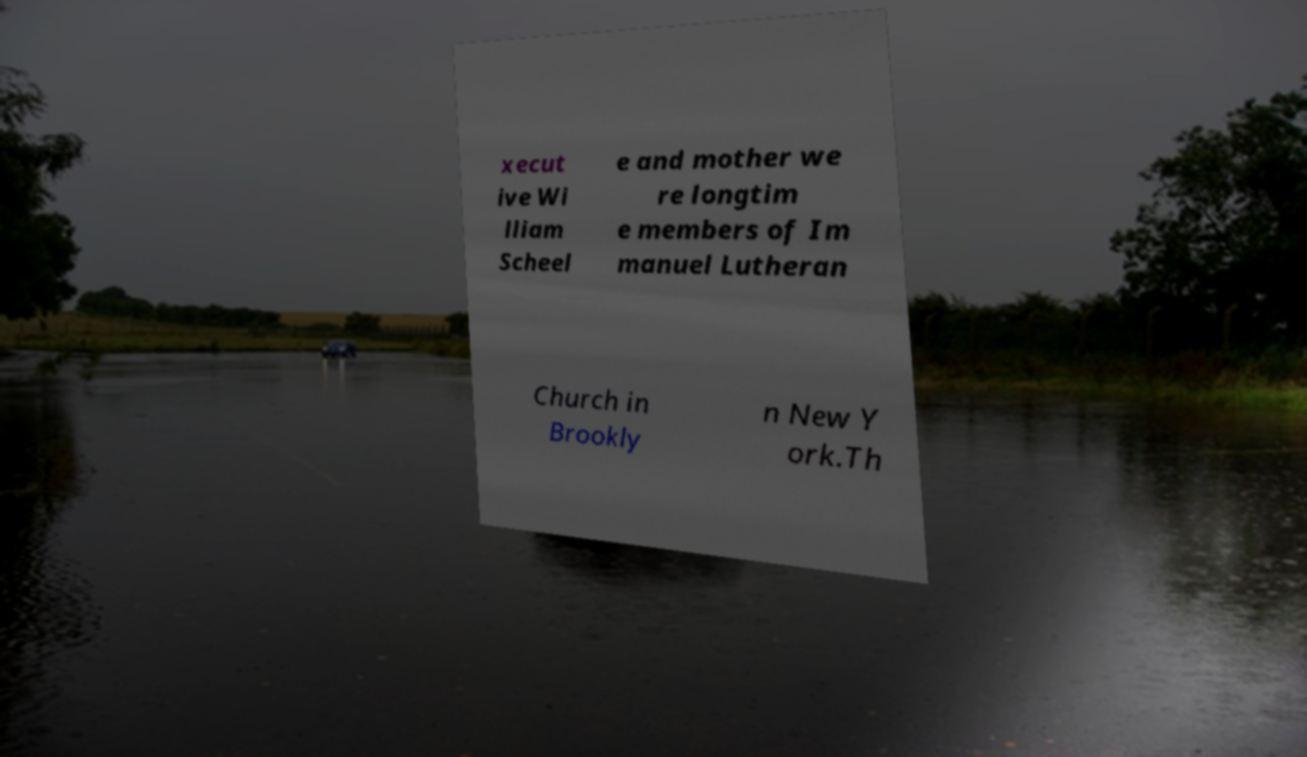Can you read and provide the text displayed in the image?This photo seems to have some interesting text. Can you extract and type it out for me? xecut ive Wi lliam Scheel e and mother we re longtim e members of Im manuel Lutheran Church in Brookly n New Y ork.Th 